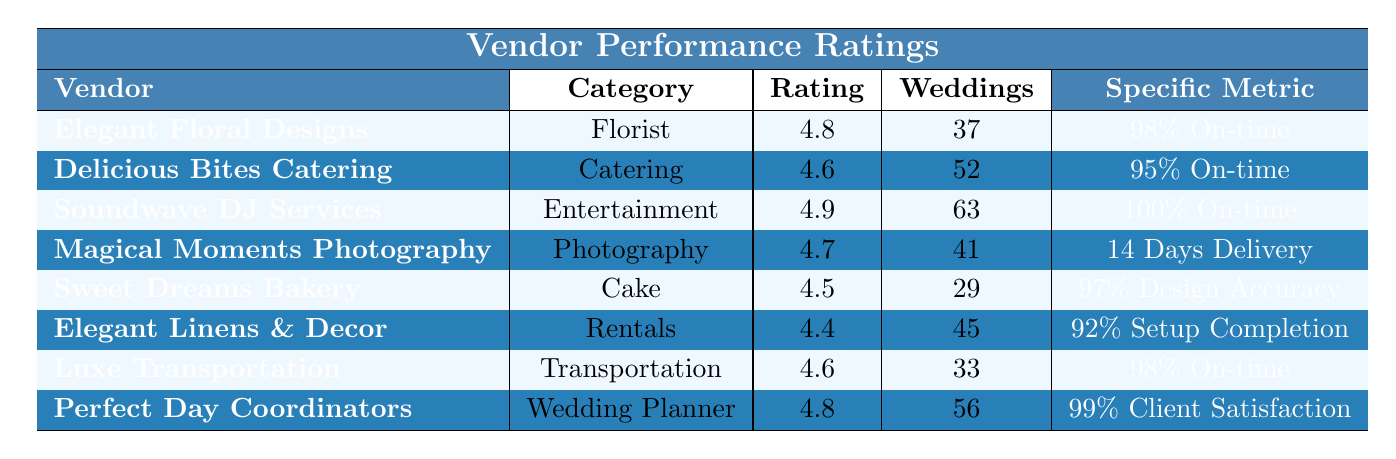What is the highest-rated vendor? The highest rating in the table is 4.9, which belongs to Soundwave DJ Services.
Answer: Soundwave DJ Services Which vendor has the most weddings serviced? Soundwave DJ Services has serviced 63 weddings, which is the highest number in the table.
Answer: Soundwave DJ Services What is the average rating of all vendors listed? The sum of all ratings is (4.8 + 4.6 + 4.9 + 4.7 + 4.5 + 4.4 + 4.6 + 4.8) = 36.3. There are 8 vendors, so the average rating is 36.3 / 8 = 4.5375, rounded to 4.54.
Answer: 4.54 Is the on-time delivery rate of Elegant Floral Designs higher than that of Delicious Bites Catering? Elegant Floral Designs has a 98% on-time delivery rate while Delicious Bites Catering has a 95% rate. Since 98% is greater than 95%, the statement is true.
Answer: Yes Which vendor has the lowest setup completion rate? Elegant Linens & Decor has a setup completion rate of 92%, which is the lowest among the listed vendors.
Answer: Elegant Linens & Decor What is the rating of the vendor with the highest client satisfaction rate? Perfect Day Coordinators has a client satisfaction rate of 99% and a rating of 4.8.
Answer: 4.8 How many vendors have a rating of 4.6 or higher? The vendors with ratings of 4.6 or higher are Elegant Floral Designs, Delicious Bites Catering, Soundwave DJ Services, Magical Moments Photography, Luxe Transportation, and Perfect Day Coordinators. This is a total of 6 vendors.
Answer: 6 What is the average on-time delivery rate of the vendors listed? The on-time delivery rates are 98%, 95%, 100%, 98%. Adding these gives 391%. Dividing by 4 yields an average of 97.75%, rounded to 97.8%.
Answer: 97.8% Is the average number of weddings serviced greater than 40? The total number of weddings serviced is (37 + 52 + 63 + 41 + 29 + 45 + 33 + 56) = 356. There are 8 vendors, so the average is 356 / 8 = 44.5. Since 44.5 is greater than 40, the statement is true.
Answer: Yes Which category has the highest on-time delivery rate? Soundwave DJ Services is the only vendor that achieved a 100% on-time delivery rate, which is the highest.
Answer: Entertainment 